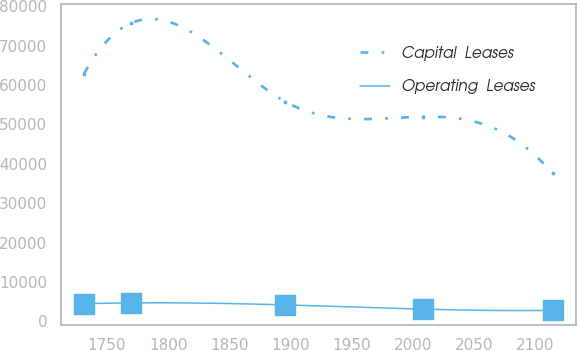<chart> <loc_0><loc_0><loc_500><loc_500><line_chart><ecel><fcel>Capital  Leases<fcel>Operating  Leases<nl><fcel>1731.17<fcel>62842.9<fcel>4490.02<nl><fcel>1769.47<fcel>75668.1<fcel>4688.36<nl><fcel>1895.85<fcel>55762.9<fcel>4188.18<nl><fcel>2008.41<fcel>51951.1<fcel>3107.83<nl><fcel>2114.18<fcel>37550<fcel>2805.33<nl></chart> 